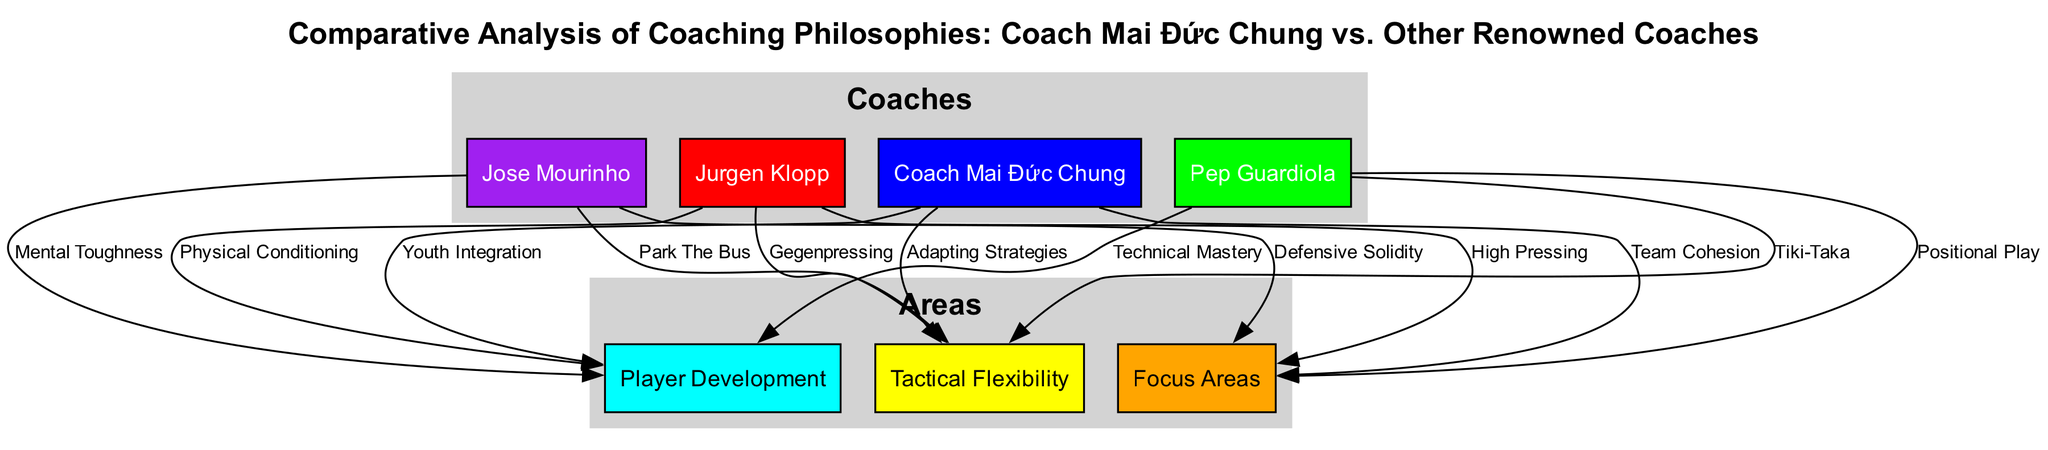What are the focus areas of Coach Mai Đức Chung? The diagram shows that Coach Mai Đức Chung is connected to the "Focus Areas" node representing "Team Cohesion."
Answer: Team Cohesion Who emphasizes Tactical Flexibility out of the four coaches? The "Tactical Flexibility" node has connections from Coach Mai Đức Chung, Pep Guardiola, Jose Mourinho, and Jurgen Klopp, indicating they all emphasize it, but Coach Mai Đức Chung's specific focus is on "Adapting Strategies."
Answer: Adapting Strategies How many nodes are related to Player Development? In the diagram, the "Player Development" node connects to Coach Mai Đức Chung, Pep Guardiola, Jose Mourinho, and Jurgen Klopp, totaling four coaches.
Answer: Four What is Pep Guardiola's approach to Player Development? The diagram shows Pep Guardiola is connected to the "Player Development" node with the label "Technical Mastery."
Answer: Technical Mastery Which coaching style is linked to "High Pressing" in the diagram? The connection between Jurgen Klopp and the "Focus Areas" node includes the label "High Pressing," indicating that his style is linked to this approach.
Answer: High Pressing What do Jose Mourinho and Jurgen Klopp have in common regarding Tactical Flexibility? Both coaches are connected to the "Tactical Flexibility" node; Mourinho emphasizes "Park The Bus," while Klopp emphasizes "Gegenpressing." This suggests both have a tactical adaptive style, though their approaches differ.
Answer: Tactical adaptive style Which coach focuses on Youth Integration for Player Development? The diagram indicates that Coach Mai Đức Chung is associated with "Player Development" through the label "Youth Integration."
Answer: Youth Integration How many edges are coming from Coach Mai Đức Chung? In the diagram, Coach Mai Đức Chung is connected to three different areas: "Focus Areas," "Player Development," and "Tactical Flexibility," indicating three edges.
Answer: Three Which coach is associated with the label "Defensive Solidity"? The edge connecting Jose Mourinho to the "Focus Areas" node features the label "Defensive Solidity," indicating that he emphasizes this aspect in his coaching philosophy.
Answer: Defensive Solidity 